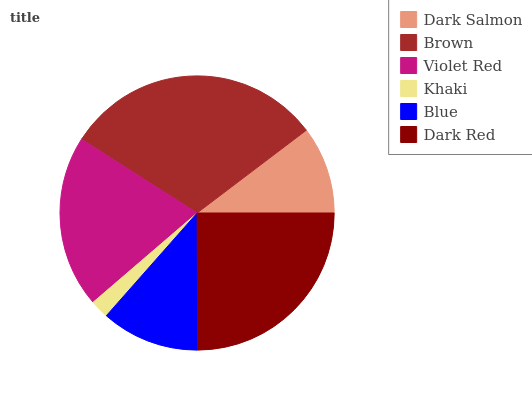Is Khaki the minimum?
Answer yes or no. Yes. Is Brown the maximum?
Answer yes or no. Yes. Is Violet Red the minimum?
Answer yes or no. No. Is Violet Red the maximum?
Answer yes or no. No. Is Brown greater than Violet Red?
Answer yes or no. Yes. Is Violet Red less than Brown?
Answer yes or no. Yes. Is Violet Red greater than Brown?
Answer yes or no. No. Is Brown less than Violet Red?
Answer yes or no. No. Is Violet Red the high median?
Answer yes or no. Yes. Is Blue the low median?
Answer yes or no. Yes. Is Brown the high median?
Answer yes or no. No. Is Dark Salmon the low median?
Answer yes or no. No. 